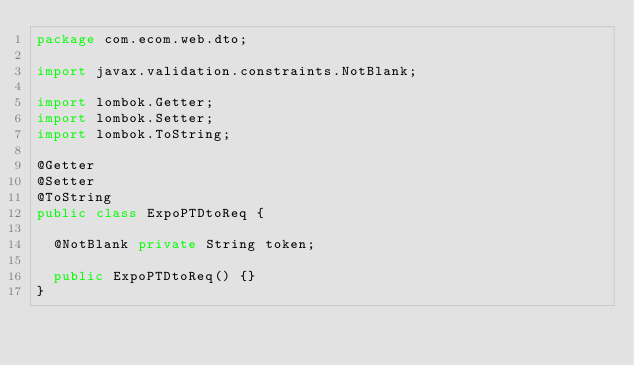<code> <loc_0><loc_0><loc_500><loc_500><_Java_>package com.ecom.web.dto;

import javax.validation.constraints.NotBlank;

import lombok.Getter;
import lombok.Setter;
import lombok.ToString;

@Getter
@Setter
@ToString
public class ExpoPTDtoReq {

  @NotBlank private String token;

  public ExpoPTDtoReq() {}
}
</code> 